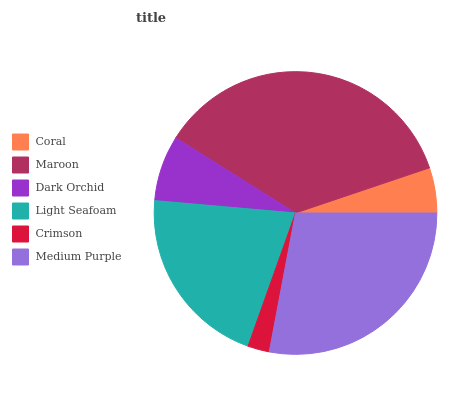Is Crimson the minimum?
Answer yes or no. Yes. Is Maroon the maximum?
Answer yes or no. Yes. Is Dark Orchid the minimum?
Answer yes or no. No. Is Dark Orchid the maximum?
Answer yes or no. No. Is Maroon greater than Dark Orchid?
Answer yes or no. Yes. Is Dark Orchid less than Maroon?
Answer yes or no. Yes. Is Dark Orchid greater than Maroon?
Answer yes or no. No. Is Maroon less than Dark Orchid?
Answer yes or no. No. Is Light Seafoam the high median?
Answer yes or no. Yes. Is Dark Orchid the low median?
Answer yes or no. Yes. Is Crimson the high median?
Answer yes or no. No. Is Medium Purple the low median?
Answer yes or no. No. 